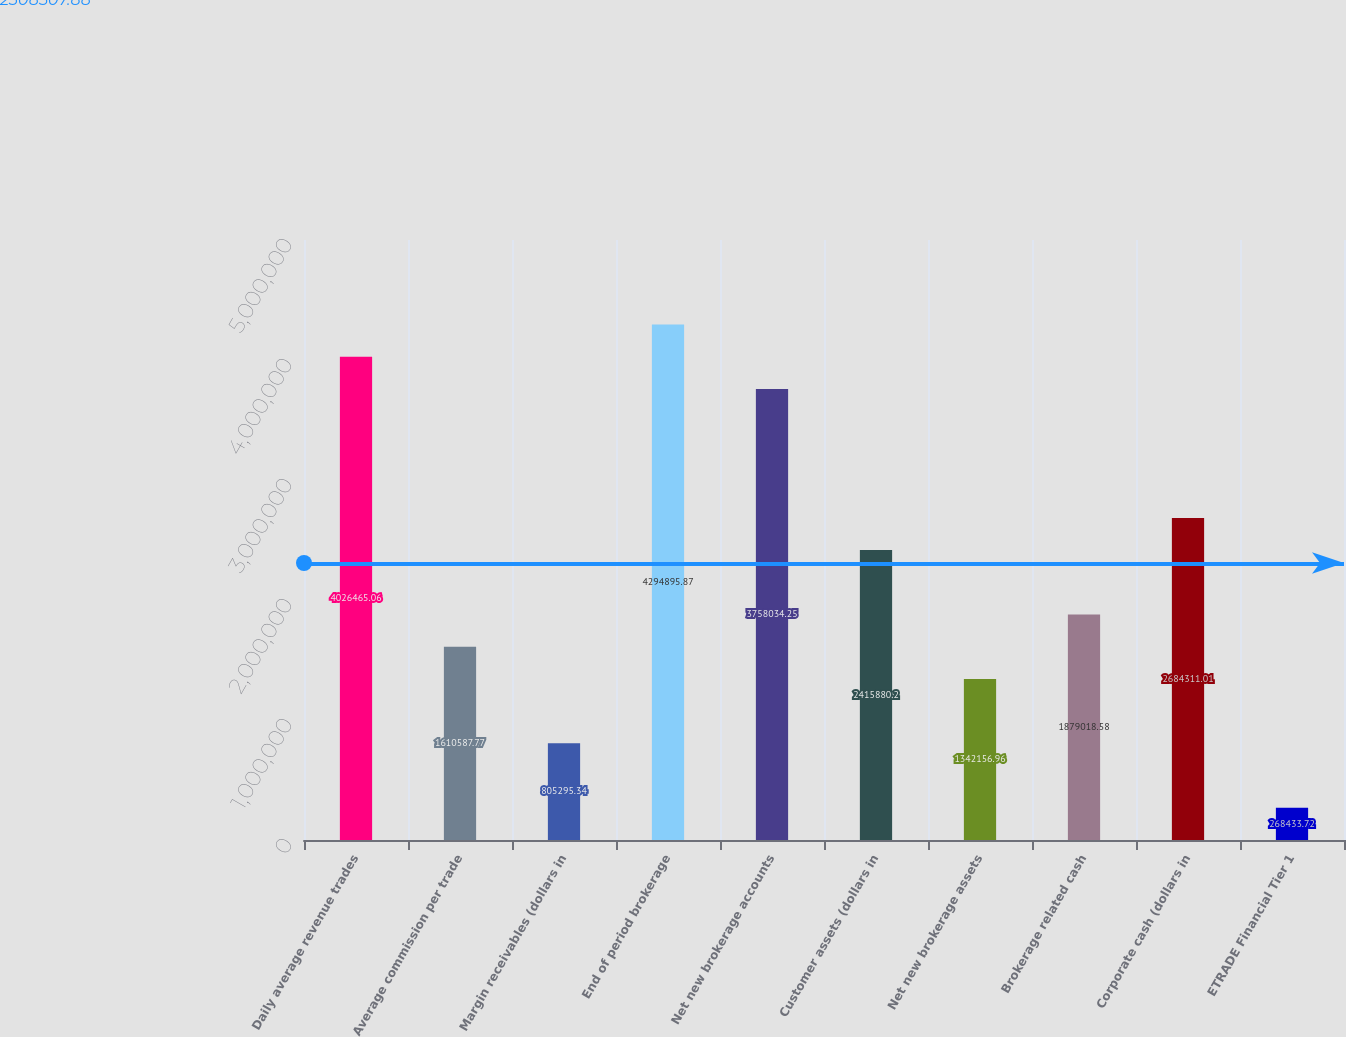<chart> <loc_0><loc_0><loc_500><loc_500><bar_chart><fcel>Daily average revenue trades<fcel>Average commission per trade<fcel>Margin receivables (dollars in<fcel>End of period brokerage<fcel>Net new brokerage accounts<fcel>Customer assets (dollars in<fcel>Net new brokerage assets<fcel>Brokerage related cash<fcel>Corporate cash (dollars in<fcel>ETRADE Financial Tier 1<nl><fcel>4.02647e+06<fcel>1.61059e+06<fcel>805295<fcel>4.2949e+06<fcel>3.75803e+06<fcel>2.41588e+06<fcel>1.34216e+06<fcel>1.87902e+06<fcel>2.68431e+06<fcel>268434<nl></chart> 